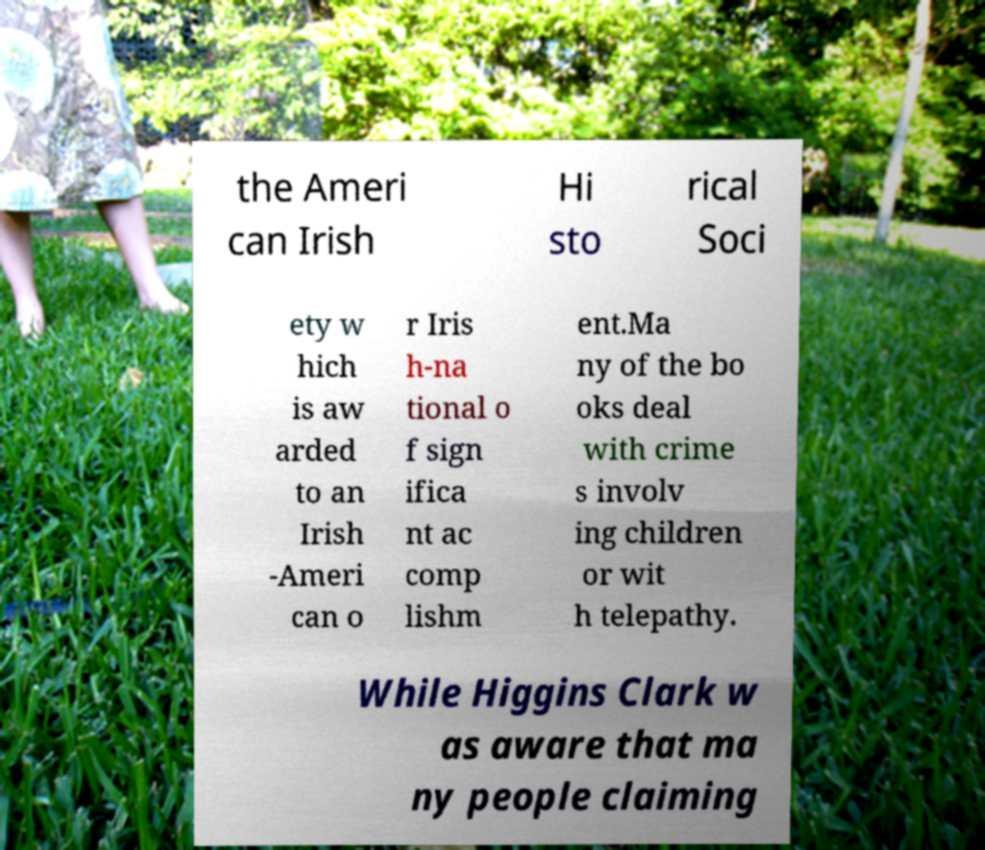Can you accurately transcribe the text from the provided image for me? the Ameri can Irish Hi sto rical Soci ety w hich is aw arded to an Irish -Ameri can o r Iris h-na tional o f sign ifica nt ac comp lishm ent.Ma ny of the bo oks deal with crime s involv ing children or wit h telepathy. While Higgins Clark w as aware that ma ny people claiming 